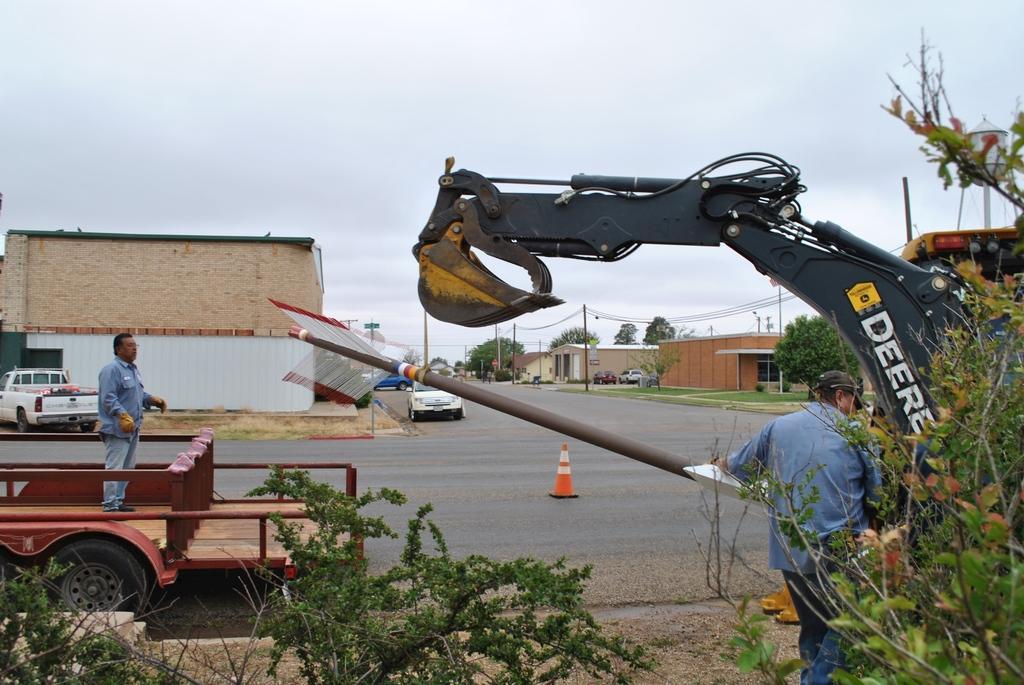Describe this image in one or two sentences. In this image I can see a road , on the road I can see vehicles, street light poles and divider block ,beside the road there is a house on the left side , there are some houses in the middle , at the bottom there are some plants, persons visible in front of crane on the right side, on the left side a person standing on vehicle ,at the top there is the sky. 